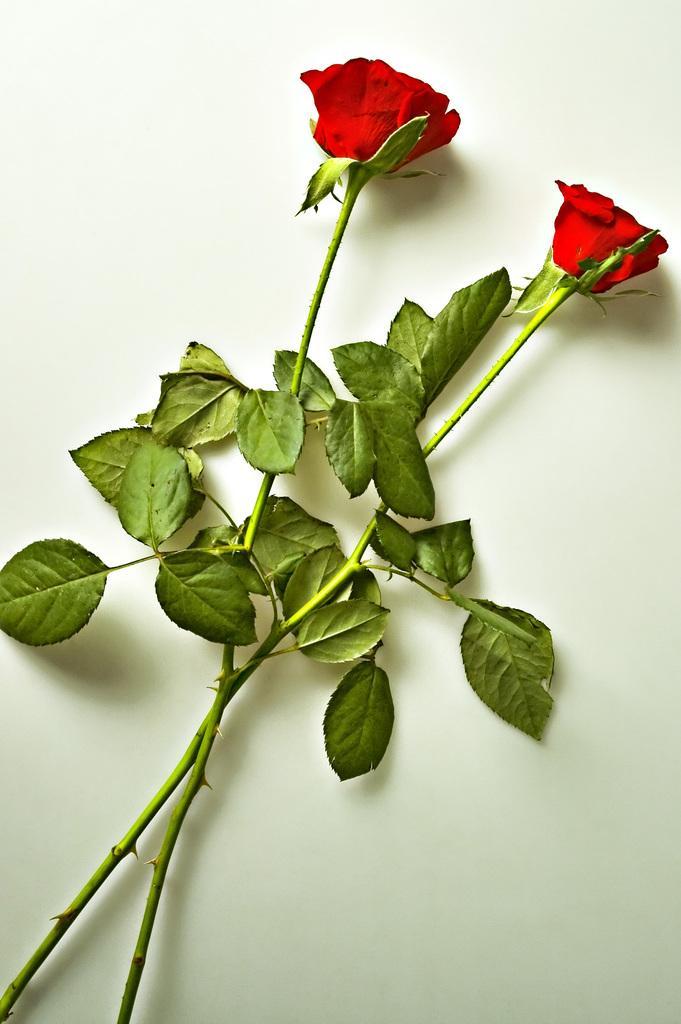Can you describe this image briefly? Here we can see two red roses with stem and leaves on a platform. 